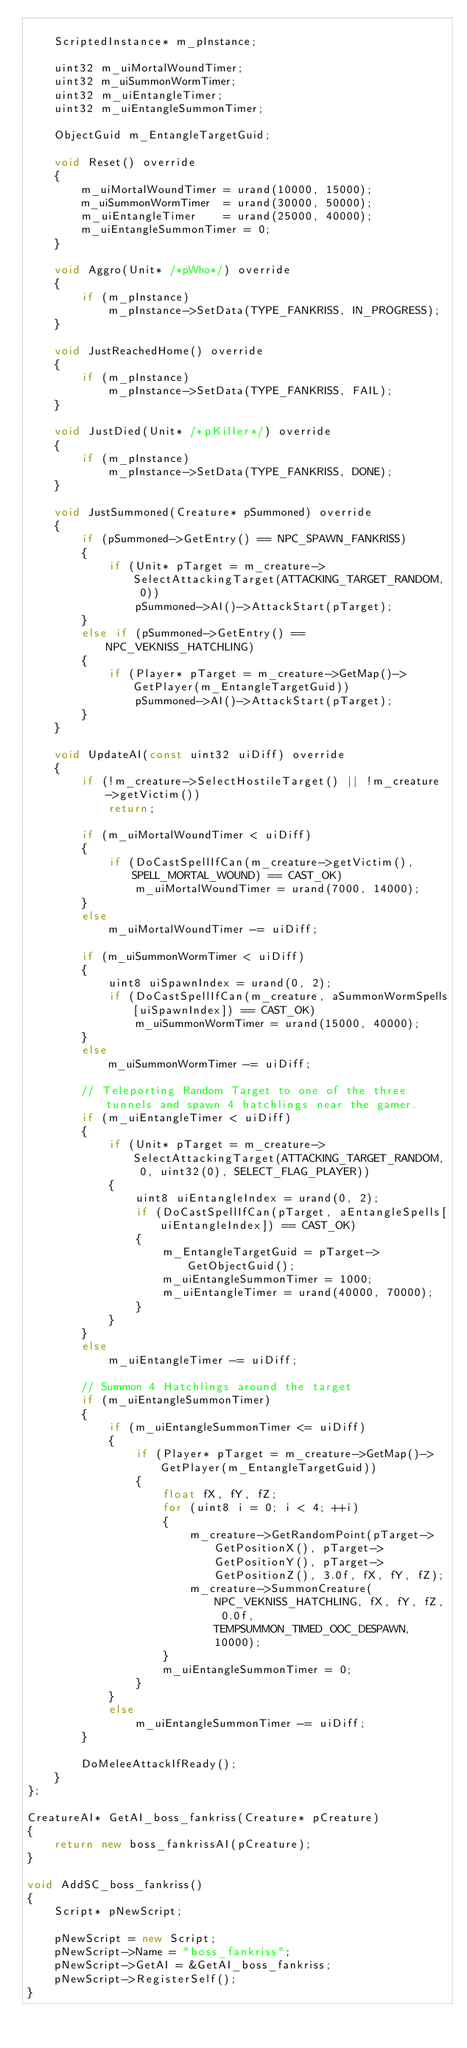Convert code to text. <code><loc_0><loc_0><loc_500><loc_500><_C++_>
    ScriptedInstance* m_pInstance;

    uint32 m_uiMortalWoundTimer;
    uint32 m_uiSummonWormTimer;
    uint32 m_uiEntangleTimer;
    uint32 m_uiEntangleSummonTimer;

    ObjectGuid m_EntangleTargetGuid;

    void Reset() override
    {
        m_uiMortalWoundTimer = urand(10000, 15000);
        m_uiSummonWormTimer  = urand(30000, 50000);
        m_uiEntangleTimer    = urand(25000, 40000);
        m_uiEntangleSummonTimer = 0;
    }

    void Aggro(Unit* /*pWho*/) override
    {
        if (m_pInstance)
            m_pInstance->SetData(TYPE_FANKRISS, IN_PROGRESS);
    }

    void JustReachedHome() override
    {
        if (m_pInstance)
            m_pInstance->SetData(TYPE_FANKRISS, FAIL);
    }

    void JustDied(Unit* /*pKiller*/) override
    {
        if (m_pInstance)
            m_pInstance->SetData(TYPE_FANKRISS, DONE);
    }

    void JustSummoned(Creature* pSummoned) override
    {
        if (pSummoned->GetEntry() == NPC_SPAWN_FANKRISS)
        {
            if (Unit* pTarget = m_creature->SelectAttackingTarget(ATTACKING_TARGET_RANDOM, 0))
                pSummoned->AI()->AttackStart(pTarget);
        }
        else if (pSummoned->GetEntry() == NPC_VEKNISS_HATCHLING)
        {
            if (Player* pTarget = m_creature->GetMap()->GetPlayer(m_EntangleTargetGuid))
                pSummoned->AI()->AttackStart(pTarget);
        }
    }

    void UpdateAI(const uint32 uiDiff) override
    {
        if (!m_creature->SelectHostileTarget() || !m_creature->getVictim())
            return;

        if (m_uiMortalWoundTimer < uiDiff)
        {
            if (DoCastSpellIfCan(m_creature->getVictim(), SPELL_MORTAL_WOUND) == CAST_OK)
                m_uiMortalWoundTimer = urand(7000, 14000);
        }
        else
            m_uiMortalWoundTimer -= uiDiff;

        if (m_uiSummonWormTimer < uiDiff)
        {
            uint8 uiSpawnIndex = urand(0, 2);
            if (DoCastSpellIfCan(m_creature, aSummonWormSpells[uiSpawnIndex]) == CAST_OK)
                m_uiSummonWormTimer = urand(15000, 40000);
        }
        else
            m_uiSummonWormTimer -= uiDiff;

        // Teleporting Random Target to one of the three tunnels and spawn 4 hatchlings near the gamer.
        if (m_uiEntangleTimer < uiDiff)
        {
            if (Unit* pTarget = m_creature->SelectAttackingTarget(ATTACKING_TARGET_RANDOM, 0, uint32(0), SELECT_FLAG_PLAYER))
            {
                uint8 uiEntangleIndex = urand(0, 2);
                if (DoCastSpellIfCan(pTarget, aEntangleSpells[uiEntangleIndex]) == CAST_OK)
                {
                    m_EntangleTargetGuid = pTarget->GetObjectGuid();
                    m_uiEntangleSummonTimer = 1000;
                    m_uiEntangleTimer = urand(40000, 70000);
                }
            }
        }
        else
            m_uiEntangleTimer -= uiDiff;

        // Summon 4 Hatchlings around the target
        if (m_uiEntangleSummonTimer)
        {
            if (m_uiEntangleSummonTimer <= uiDiff)
            {
                if (Player* pTarget = m_creature->GetMap()->GetPlayer(m_EntangleTargetGuid))
                {
                    float fX, fY, fZ;
                    for (uint8 i = 0; i < 4; ++i)
                    {
                        m_creature->GetRandomPoint(pTarget->GetPositionX(), pTarget->GetPositionY(), pTarget->GetPositionZ(), 3.0f, fX, fY, fZ);
                        m_creature->SummonCreature(NPC_VEKNISS_HATCHLING, fX, fY, fZ, 0.0f, TEMPSUMMON_TIMED_OOC_DESPAWN, 10000);
                    }
                    m_uiEntangleSummonTimer = 0;
                }
            }
            else
                m_uiEntangleSummonTimer -= uiDiff;
        }

        DoMeleeAttackIfReady();
    }
};

CreatureAI* GetAI_boss_fankriss(Creature* pCreature)
{
    return new boss_fankrissAI(pCreature);
}

void AddSC_boss_fankriss()
{
    Script* pNewScript;

    pNewScript = new Script;
    pNewScript->Name = "boss_fankriss";
    pNewScript->GetAI = &GetAI_boss_fankriss;
    pNewScript->RegisterSelf();
}
</code> 